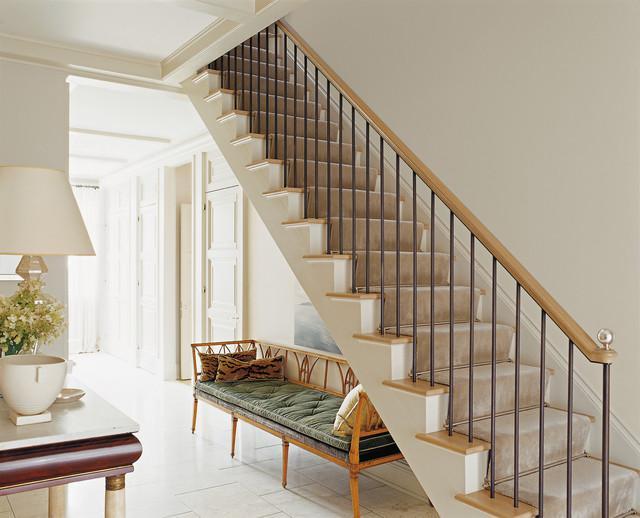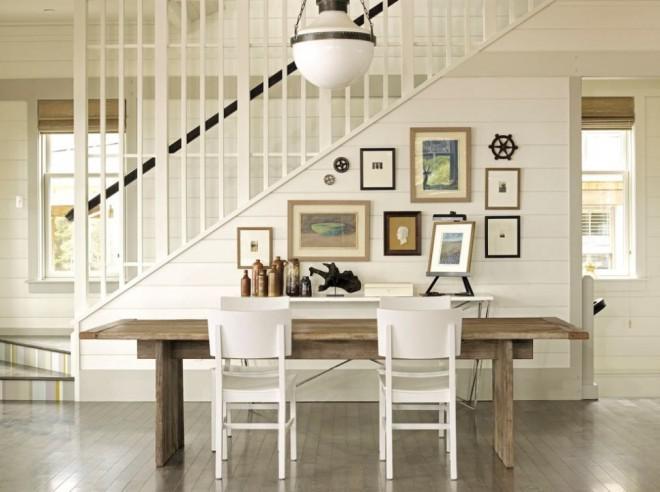The first image is the image on the left, the second image is the image on the right. Analyze the images presented: Is the assertion "The stairs in each image are going up toward the other image." valid? Answer yes or no. No. The first image is the image on the left, the second image is the image on the right. Examine the images to the left and right. Is the description "There is a curved staircase." accurate? Answer yes or no. No. 